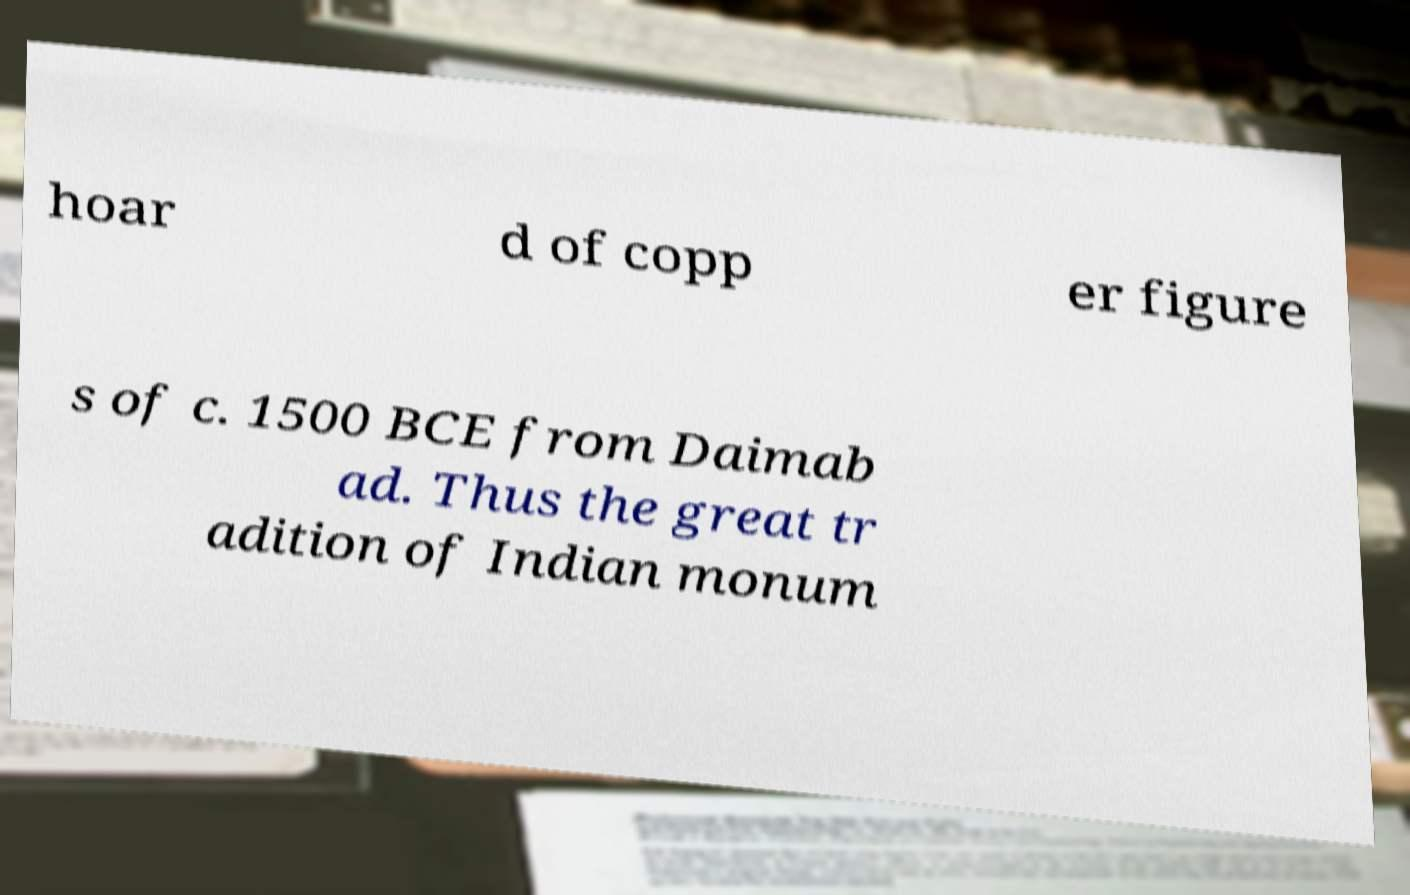Can you accurately transcribe the text from the provided image for me? hoar d of copp er figure s of c. 1500 BCE from Daimab ad. Thus the great tr adition of Indian monum 